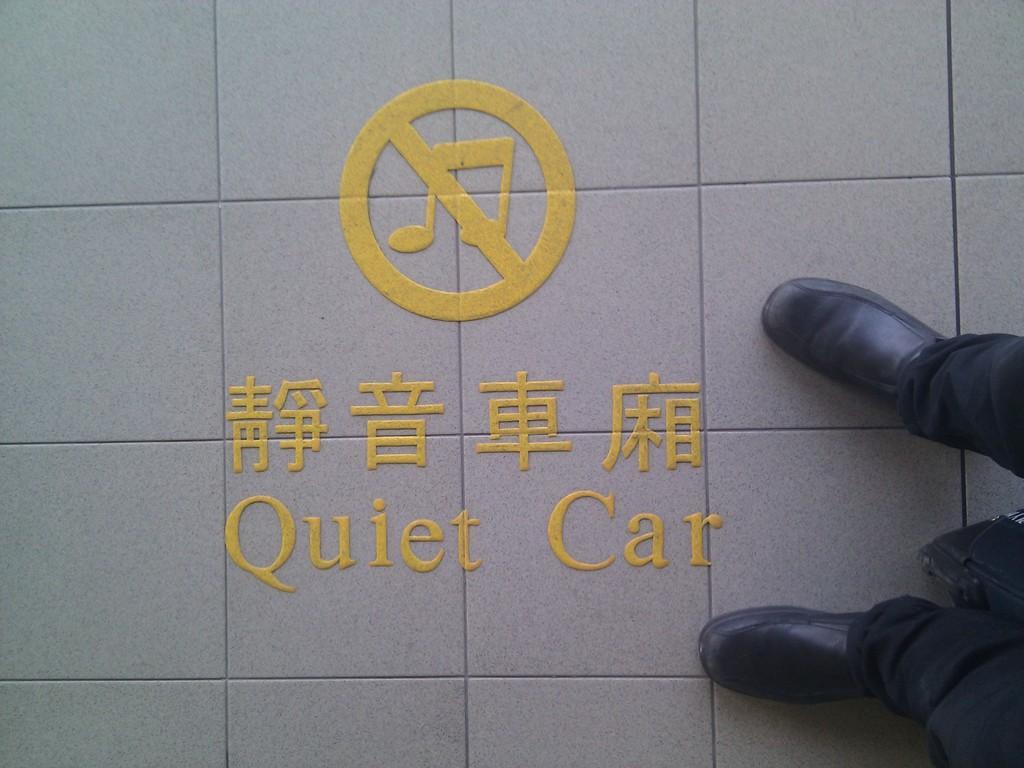Could you give a brief overview of what you see in this image? This image consists of a man wearing black shoes and a black pant is standing on the floor. And we can see a text on the floor. 